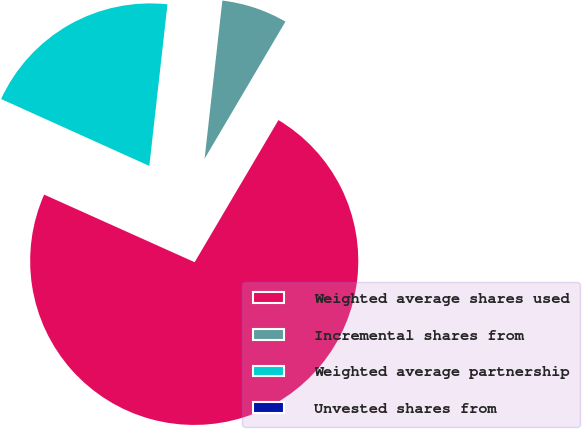Convert chart to OTSL. <chart><loc_0><loc_0><loc_500><loc_500><pie_chart><fcel>Weighted average shares used<fcel>Incremental shares from<fcel>Weighted average partnership<fcel>Unvested shares from<nl><fcel>73.24%<fcel>6.7%<fcel>20.03%<fcel>0.03%<nl></chart> 